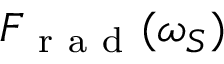<formula> <loc_0><loc_0><loc_500><loc_500>F _ { r a d } ( \omega _ { S } )</formula> 